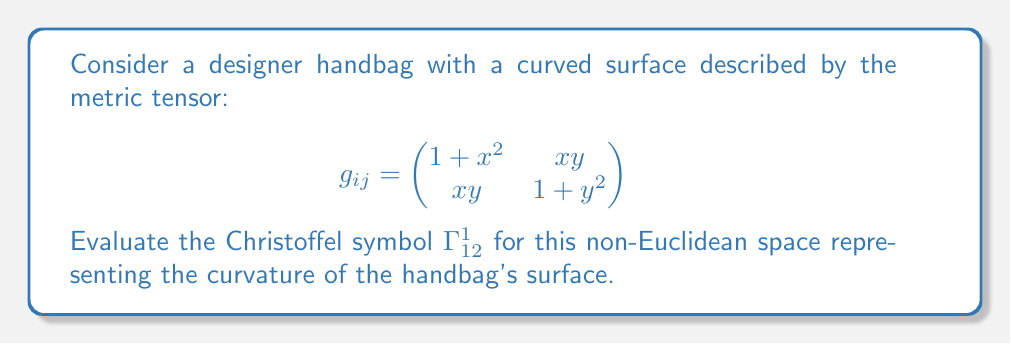Help me with this question. To evaluate the Christoffel symbol $\Gamma^1_{12}$, we'll use the formula:

$$\Gamma^k_{ij} = \frac{1}{2}g^{kl}\left(\frac{\partial g_{jl}}{\partial x^i} + \frac{\partial g_{il}}{\partial x^j} - \frac{\partial g_{ij}}{\partial x^l}\right)$$

Step 1: Calculate the inverse metric tensor $g^{ij}$:
$$g^{ij} = \frac{1}{(1+x^2)(1+y^2)-x^2y^2}\begin{pmatrix}
1+y^2 & -xy \\
-xy & 1+x^2
\end{pmatrix}$$

Step 2: Calculate the partial derivatives:
$$\frac{\partial g_{12}}{\partial x^1} = \frac{\partial (xy)}{\partial x} = y$$
$$\frac{\partial g_{11}}{\partial x^2} = \frac{\partial (1+x^2)}{\partial y} = 0$$
$$\frac{\partial g_{12}}{\partial x^1} = \frac{\partial (xy)}{\partial x} = y$$

Step 3: Apply the formula for $\Gamma^1_{12}$:
$$\Gamma^1_{12} = \frac{1}{2}[g^{11}(\frac{\partial g_{21}}{\partial x^1} + \frac{\partial g_{11}}{\partial x^2} - \frac{\partial g_{12}}{\partial x^1}) + g^{12}(\frac{\partial g_{22}}{\partial x^1} + \frac{\partial g_{12}}{\partial x^2} - \frac{\partial g_{12}}{\partial x^2})]$$

$$\Gamma^1_{12} = \frac{1}{2}[\frac{1+y^2}{(1+x^2)(1+y^2)-x^2y^2}(y + 0 - y) + \frac{-xy}{(1+x^2)(1+y^2)-x^2y^2}(x + y - y)]$$

Step 4: Simplify:
$$\Gamma^1_{12} = \frac{1}{2}[\frac{-x^2y}{(1+x^2)(1+y^2)-x^2y^2}] = \frac{-x^2y}{2[(1+x^2)(1+y^2)-x^2y^2]}$$
Answer: $\Gamma^1_{12} = \frac{-x^2y}{2[(1+x^2)(1+y^2)-x^2y^2]}$ 